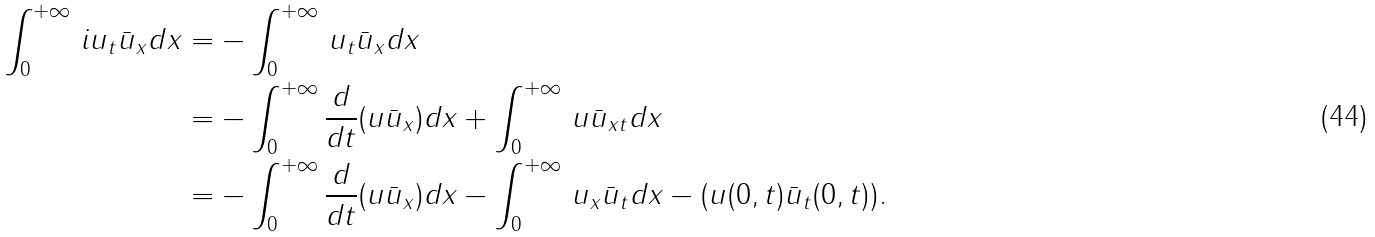Convert formula to latex. <formula><loc_0><loc_0><loc_500><loc_500>\int _ { 0 } ^ { + \infty } \, i u _ { t } \bar { u } _ { x } d x & = - \int _ { 0 } ^ { + \infty } \, u _ { t } \bar { u } _ { x } d x \\ & = - \int _ { 0 } ^ { + \infty } \frac { d } { d t } ( u \bar { u } _ { x } ) d x + \int _ { 0 } ^ { + \infty } \, u \bar { u } _ { x t } d x \\ & = - \int _ { 0 } ^ { + \infty } \frac { d } { d t } ( u \bar { u } _ { x } ) d x - \int _ { 0 } ^ { + \infty } \, u _ { x } \bar { u } _ { t } d x - ( u ( 0 , t ) \bar { u } _ { t } ( 0 , t ) ) .</formula> 